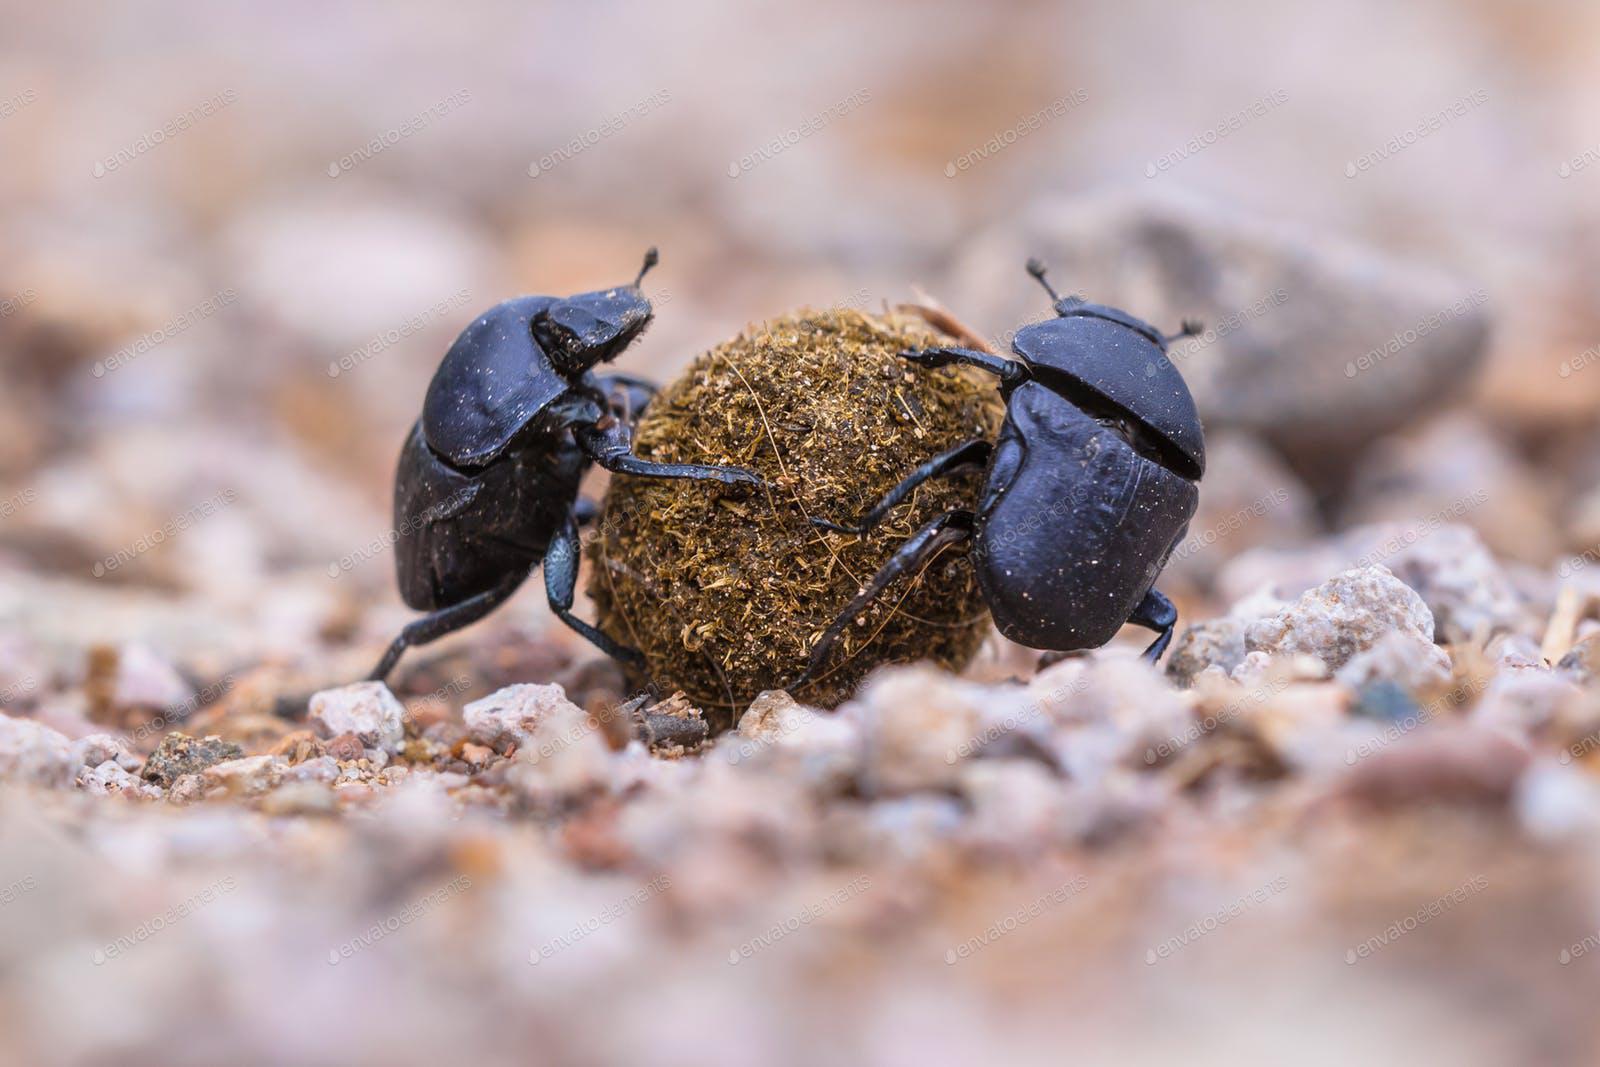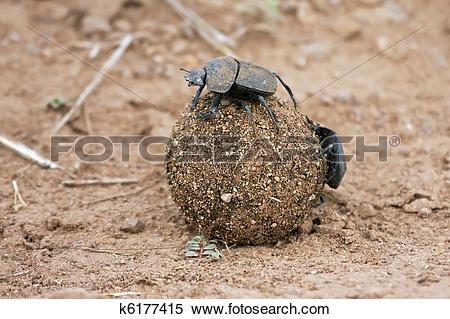The first image is the image on the left, the second image is the image on the right. Given the left and right images, does the statement "There are at least three beetles." hold true? Answer yes or no. Yes. The first image is the image on the left, the second image is the image on the right. Analyze the images presented: Is the assertion "There are two dung beetles in the image on the right." valid? Answer yes or no. Yes. 